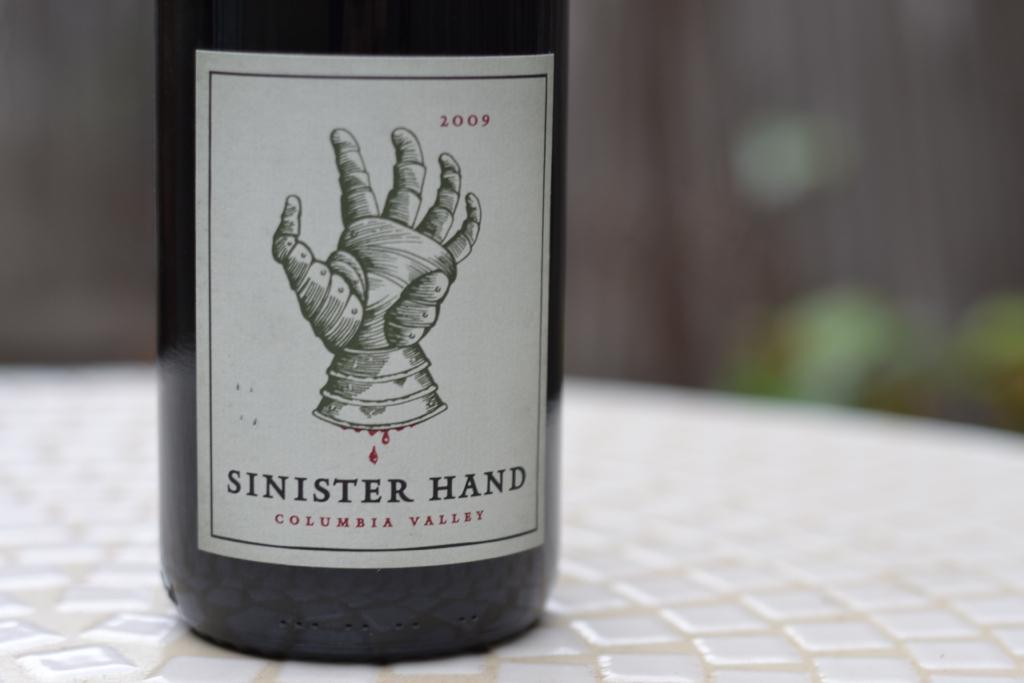Please provide a concise description of this image. In this image there is a label on the bottle, On the label there is picture of hand and some text on it, the bottle is on the table.  